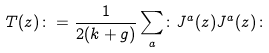Convert formula to latex. <formula><loc_0><loc_0><loc_500><loc_500>T ( z ) \colon = \frac { 1 } { 2 ( k + g ) } \sum _ { a } \colon J ^ { a } ( z ) J ^ { a } ( z ) \colon</formula> 